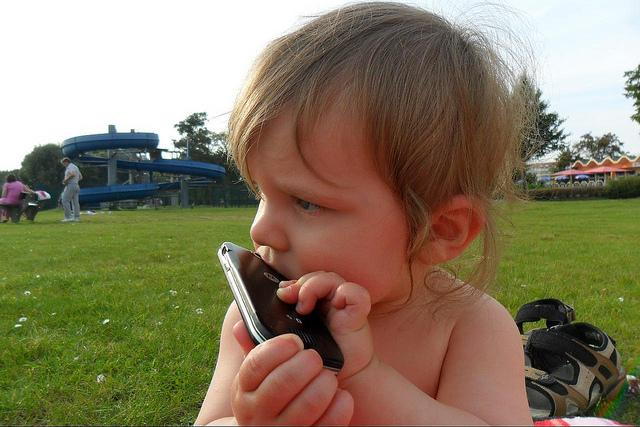What is the baby doing to the phone?

Choices:
A) eating
B) pressing buttons
C) staring at
D) throwing eating 